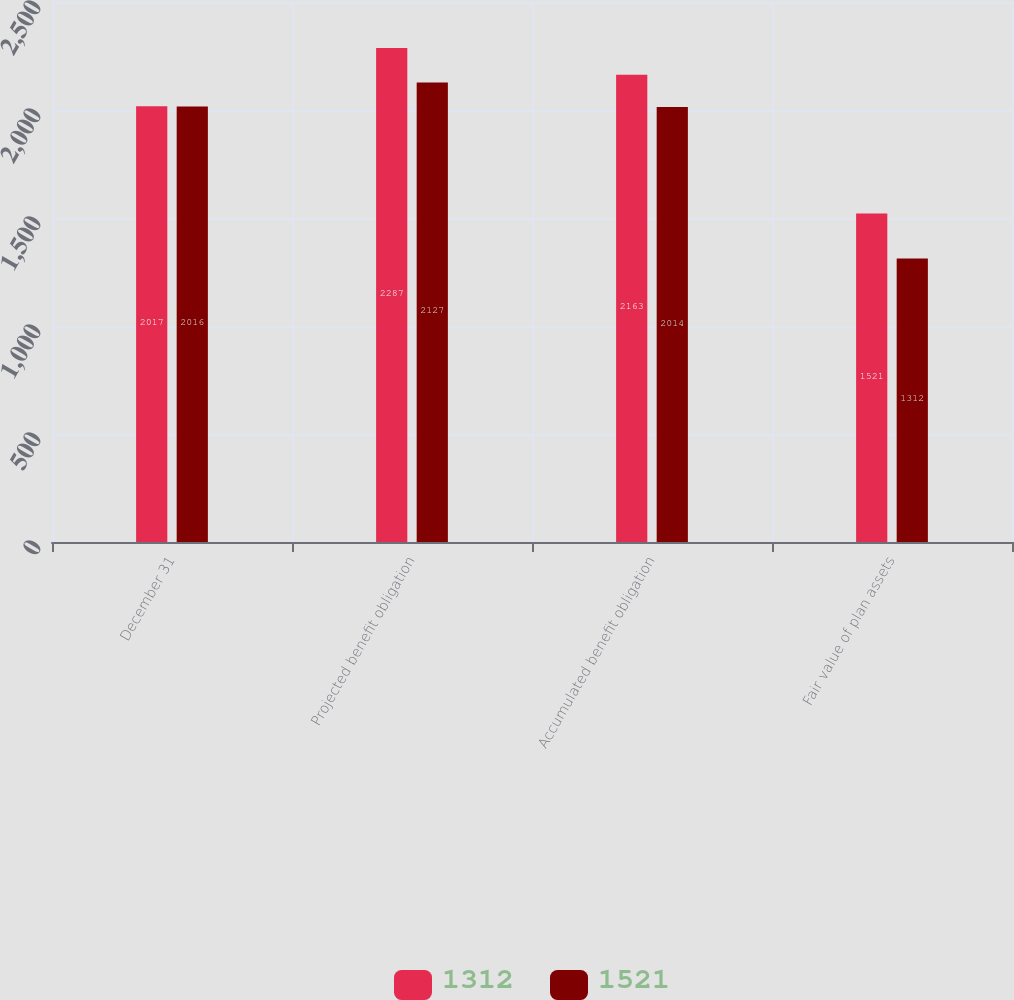Convert chart to OTSL. <chart><loc_0><loc_0><loc_500><loc_500><stacked_bar_chart><ecel><fcel>December 31<fcel>Projected benefit obligation<fcel>Accumulated benefit obligation<fcel>Fair value of plan assets<nl><fcel>1312<fcel>2017<fcel>2287<fcel>2163<fcel>1521<nl><fcel>1521<fcel>2016<fcel>2127<fcel>2014<fcel>1312<nl></chart> 